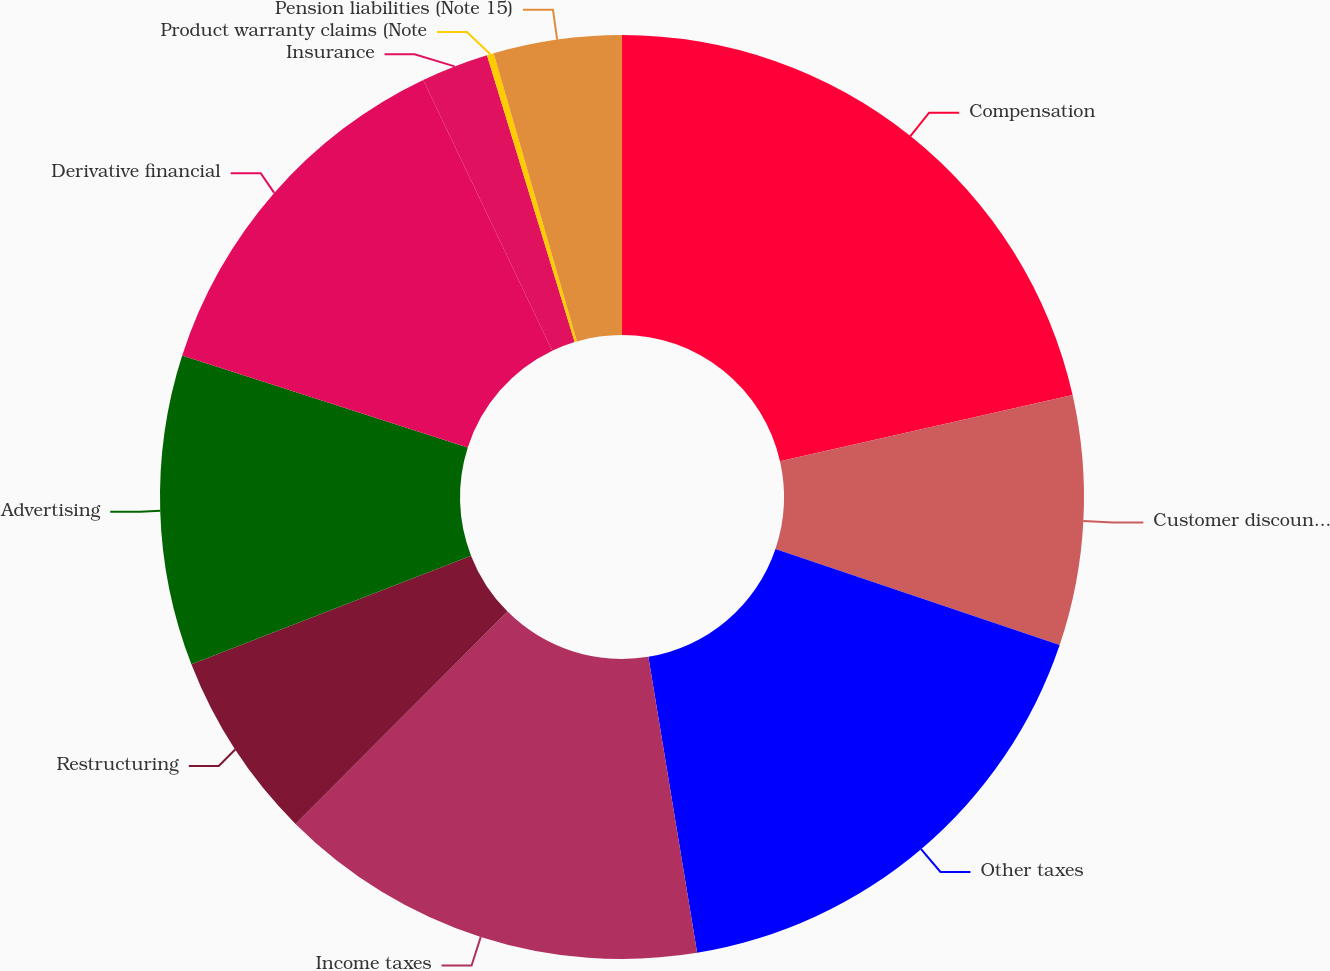<chart> <loc_0><loc_0><loc_500><loc_500><pie_chart><fcel>Compensation<fcel>Customer discounts and<fcel>Other taxes<fcel>Income taxes<fcel>Restructuring<fcel>Advertising<fcel>Derivative financial<fcel>Insurance<fcel>Product warranty claims (Note<fcel>Pension liabilities (Note 15)<nl><fcel>21.46%<fcel>8.73%<fcel>17.21%<fcel>15.09%<fcel>6.61%<fcel>10.85%<fcel>12.97%<fcel>2.36%<fcel>0.24%<fcel>4.48%<nl></chart> 